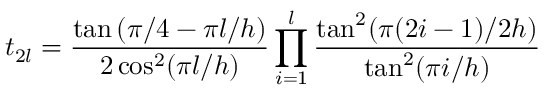Convert formula to latex. <formula><loc_0><loc_0><loc_500><loc_500>t _ { 2 l } = \frac { \tan \left ( \pi / 4 - \pi l / h \right ) } { 2 \cos ^ { 2 } ( \pi l / h ) } \prod _ { i = 1 } ^ { l } \frac { \tan ^ { 2 } ( \pi ( 2 i - 1 ) / 2 h ) } { \tan ^ { 2 } ( \pi i / h ) }</formula> 